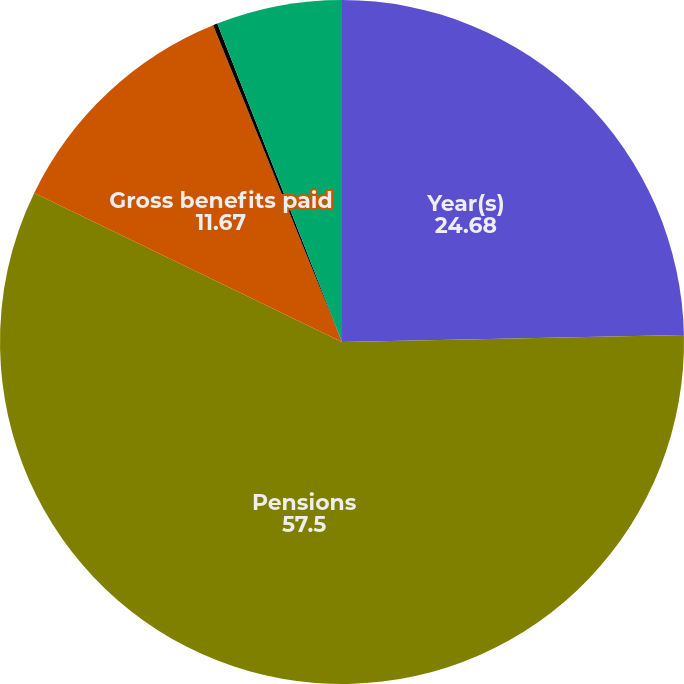Convert chart. <chart><loc_0><loc_0><loc_500><loc_500><pie_chart><fcel>Year(s)<fcel>Pensions<fcel>Gross benefits paid<fcel>Subsidies<fcel>Net other postretirement<nl><fcel>24.68%<fcel>57.5%<fcel>11.67%<fcel>0.21%<fcel>5.94%<nl></chart> 